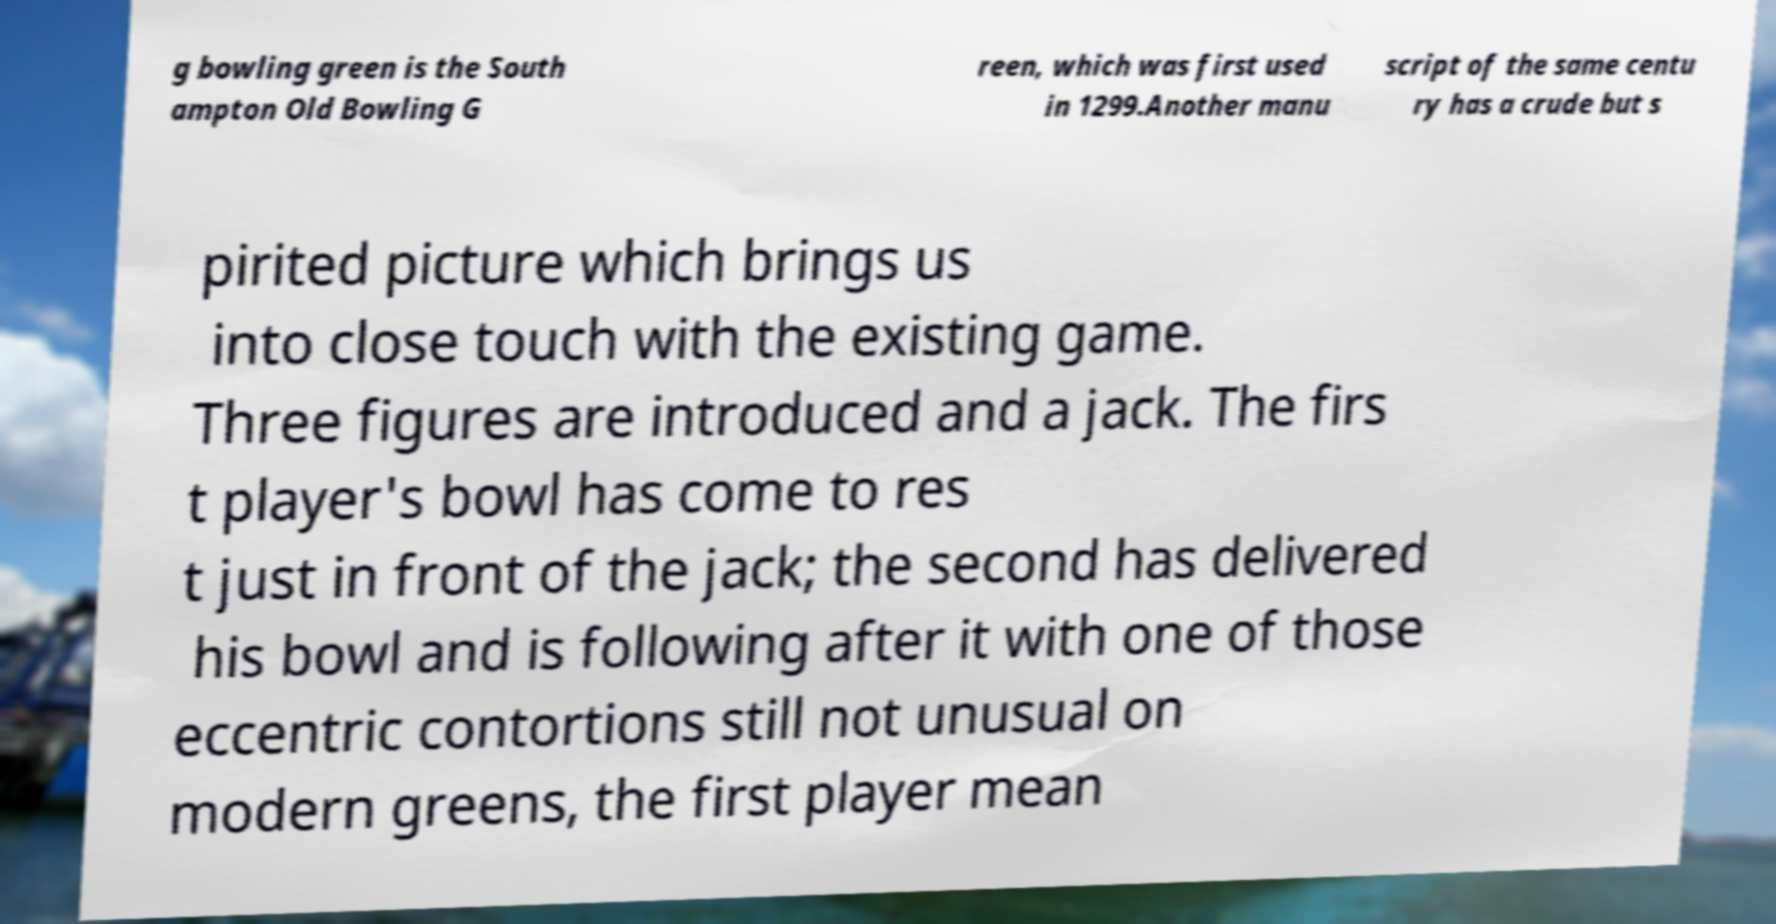Could you extract and type out the text from this image? g bowling green is the South ampton Old Bowling G reen, which was first used in 1299.Another manu script of the same centu ry has a crude but s pirited picture which brings us into close touch with the existing game. Three figures are introduced and a jack. The firs t player's bowl has come to res t just in front of the jack; the second has delivered his bowl and is following after it with one of those eccentric contortions still not unusual on modern greens, the first player mean 